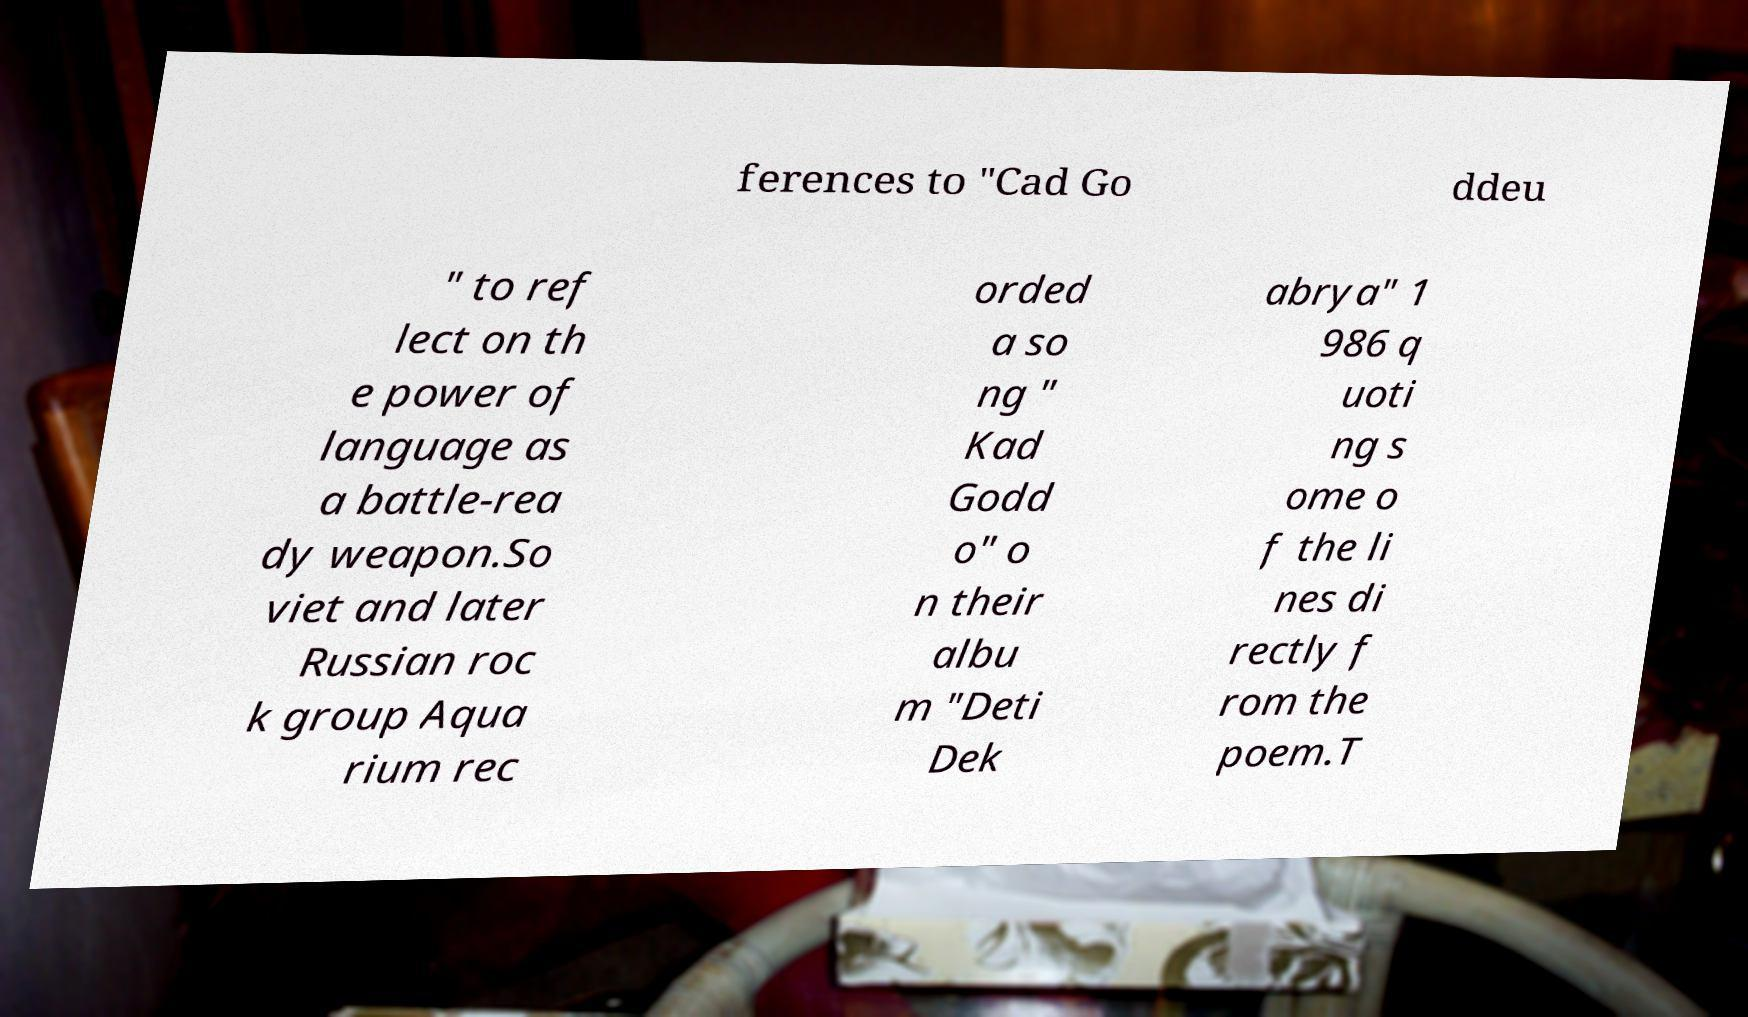Please read and relay the text visible in this image. What does it say? ferences to "Cad Go ddeu " to ref lect on th e power of language as a battle-rea dy weapon.So viet and later Russian roc k group Aqua rium rec orded a so ng " Kad Godd o" o n their albu m "Deti Dek abrya" 1 986 q uoti ng s ome o f the li nes di rectly f rom the poem.T 